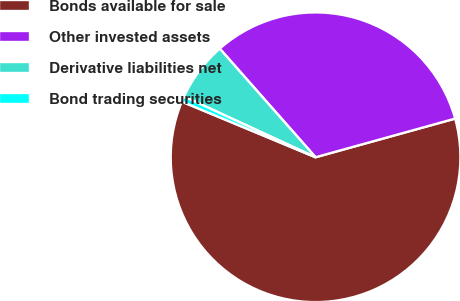<chart> <loc_0><loc_0><loc_500><loc_500><pie_chart><fcel>Bonds available for sale<fcel>Other invested assets<fcel>Derivative liabilities net<fcel>Bond trading securities<nl><fcel>60.57%<fcel>32.2%<fcel>6.61%<fcel>0.61%<nl></chart> 